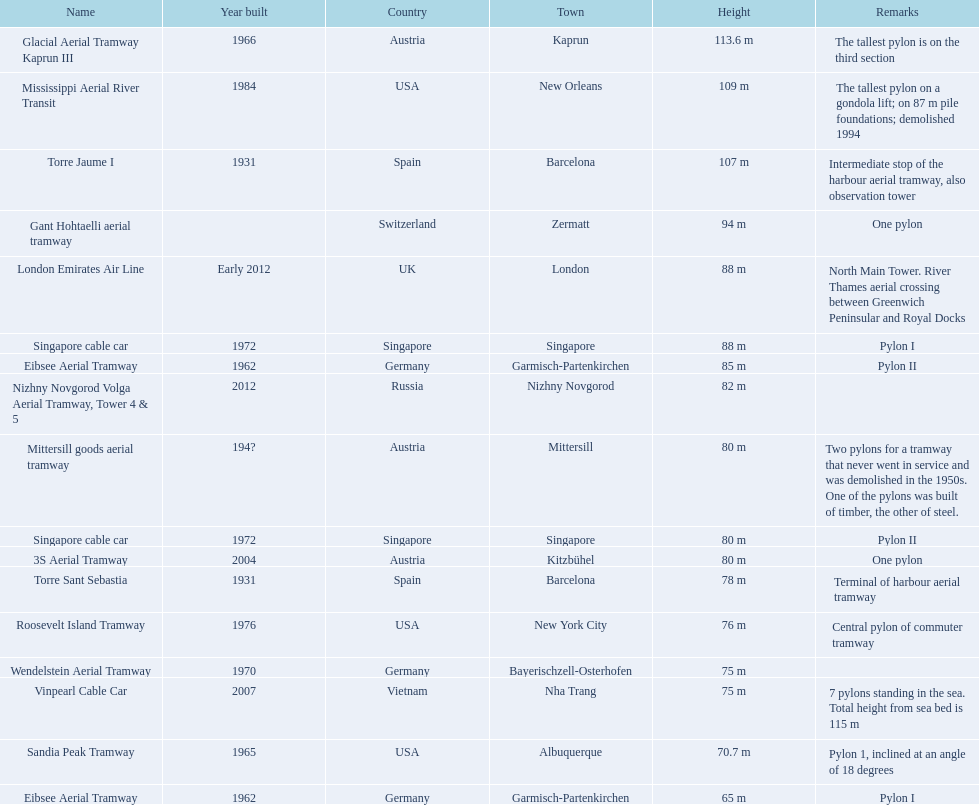How many aerial lift supports on the list are found in the usa? Mississippi Aerial River Transit, Roosevelt Island Tramway, Sandia Peak Tramway. Of the supports found in the usa, how many were erected after 1970? Mississippi Aerial River Transit, Roosevelt Island Tramway. Of the supports erected after 1970, which is the loftiest support on a gondola lift? Mississippi Aerial River Transit. How many meters is the loftiest support on a gondola lift? 109 m. 